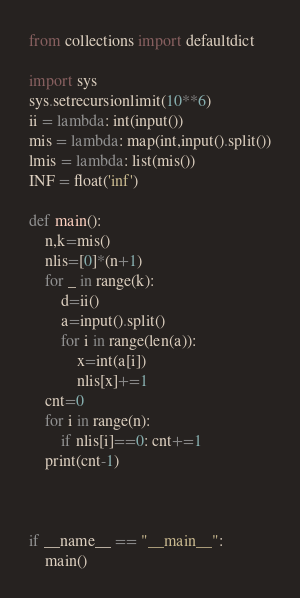<code> <loc_0><loc_0><loc_500><loc_500><_Python_>from collections import defaultdict

import sys
sys.setrecursionlimit(10**6)
ii = lambda: int(input())
mis = lambda: map(int,input().split())
lmis = lambda: list(mis())
INF = float('inf')

def main():
    n,k=mis()
    nlis=[0]*(n+1)
    for _ in range(k):
        d=ii()
        a=input().split()
        for i in range(len(a)):
            x=int(a[i])
            nlis[x]+=1
    cnt=0
    for i in range(n):
        if nlis[i]==0: cnt+=1
    print(cnt-1)



if __name__ == "__main__":
    main()</code> 